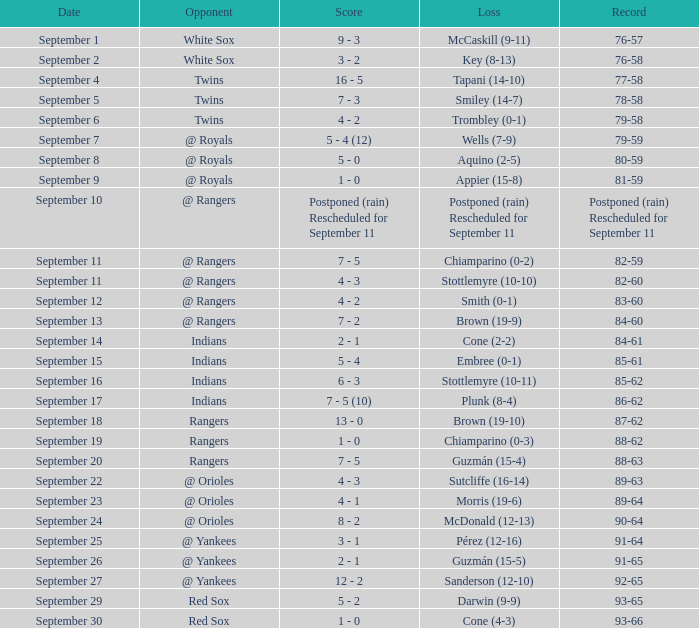What opponent has a loss of McCaskill (9-11)? White Sox. 